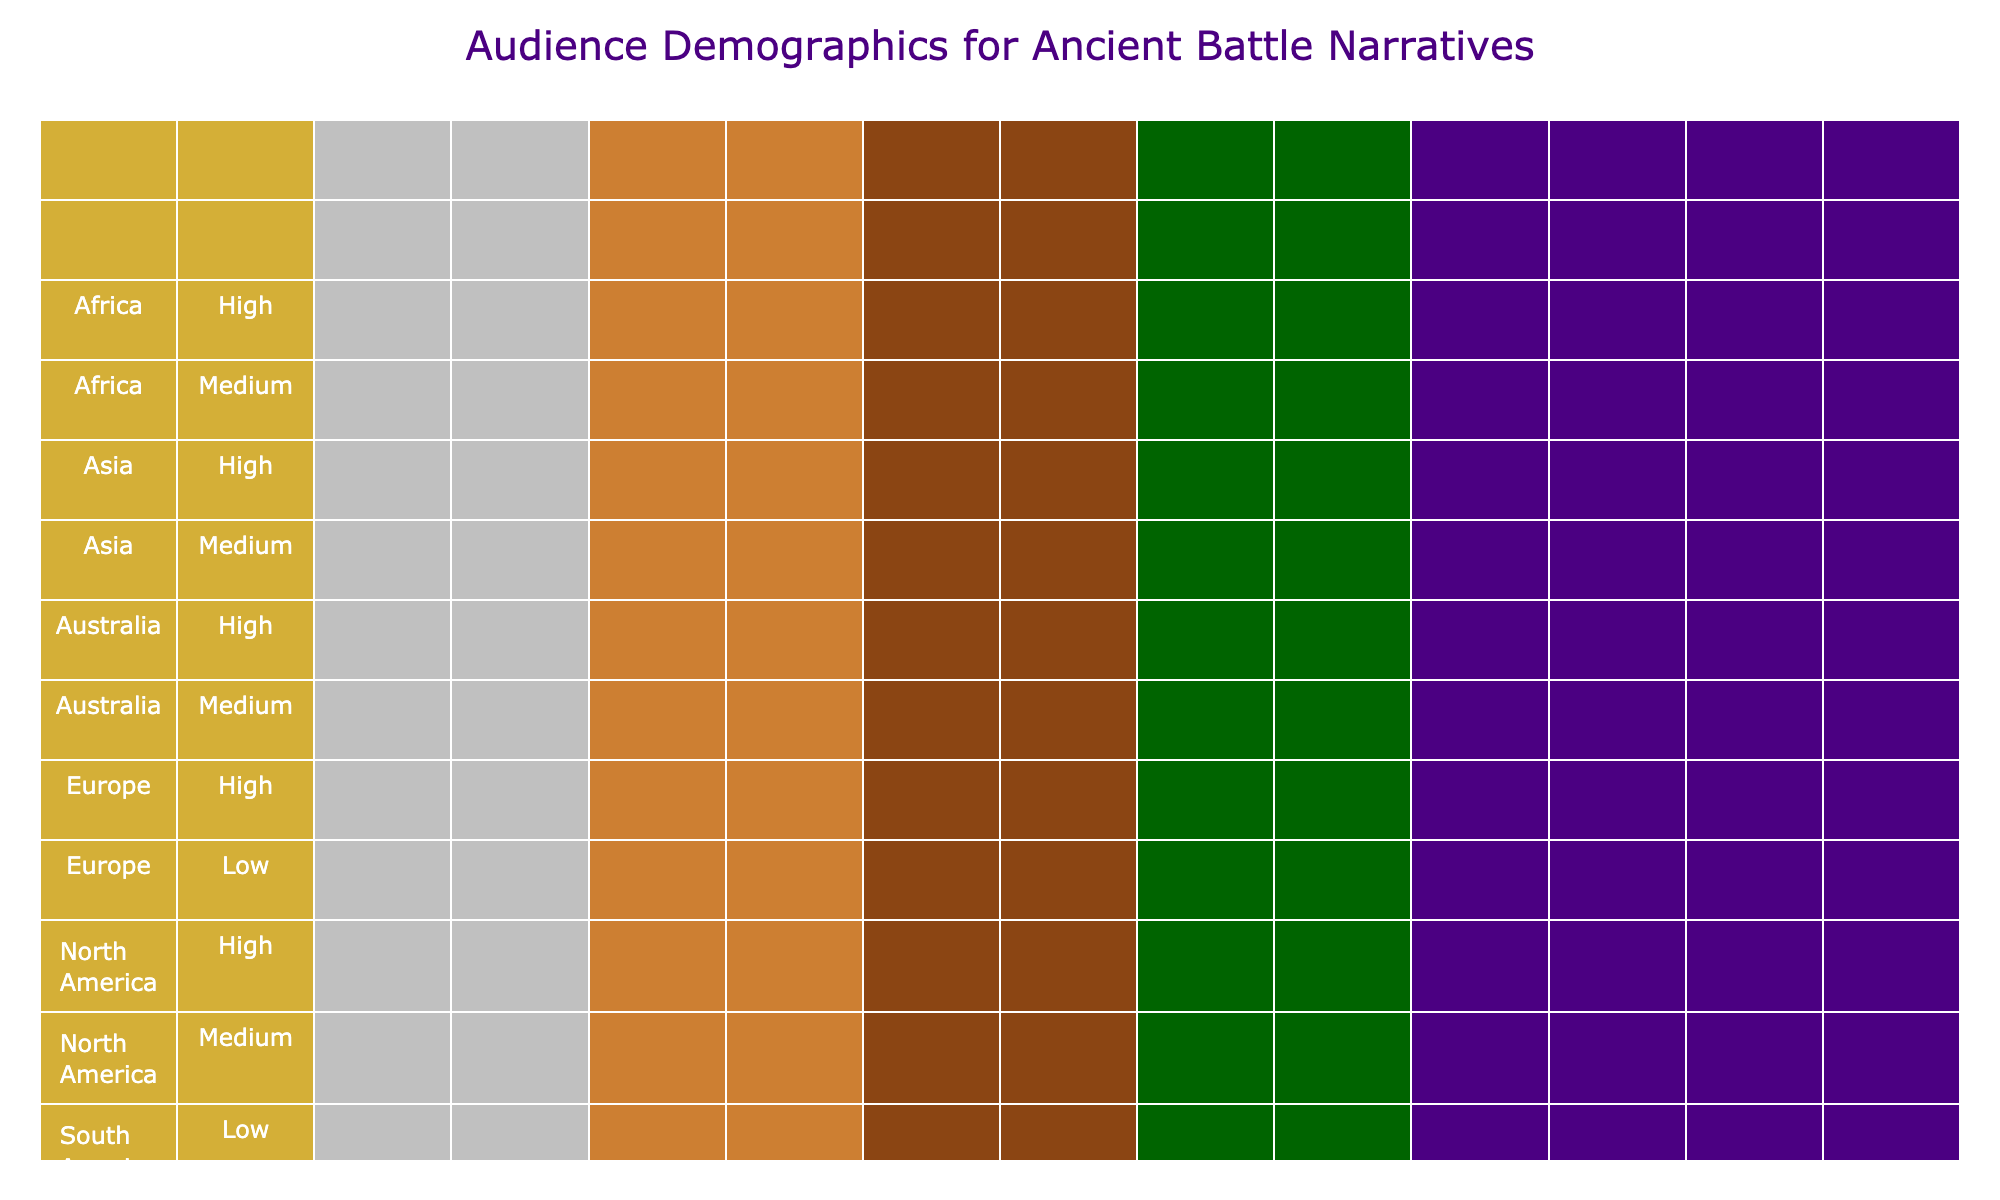What is the highest interest level for males in North America? From the table, the only demographic under the "North America" region with a "High" interest level is the "18-24" age group for males, who show a high interest in ancient battle narratives.
Answer: High How many females in Asia have a medium interest level? Looking at the table, under the "Asia" region, there is one entry for females with a "Medium" interest level in the "35-44" age group, confirming there is only one female in this region with medium interest.
Answer: 1 Is there a high interest level for any females in Southern America? In the "South America" region, there are two entries for females: "45-54" with a "Medium" interest level and none express a "High" interest level. Thus, there is no high interest level for females in this region.
Answer: No What is the total number of respondents between the age groups 25-34 and 45-54? Based on the table, we count the entries for age group "25-34": 2 (one male, one female) and for age group "45-54": 2 (one male, one female). Adding them gives us 2 + 2 = 4.
Answer: 4 Which age group shows the least interest level among females in Europe? In Europe, we see that the only female demographic is from the "25-34" age group, which has a "Low" interest level while all others have either medium or high for males. Hence it concludes that females in this age group show the least interest.
Answer: 25-34 (Low) 